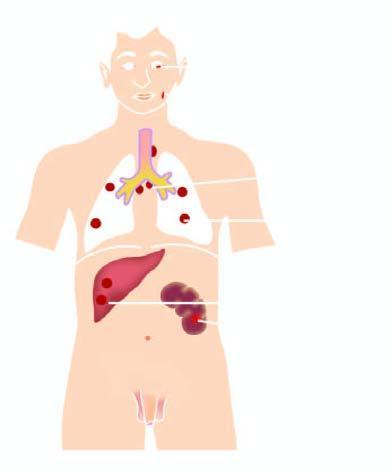what are the lesions predominantly seen in?
Answer the question using a single word or phrase. Lymph nodes and throughout lung parenchyma 